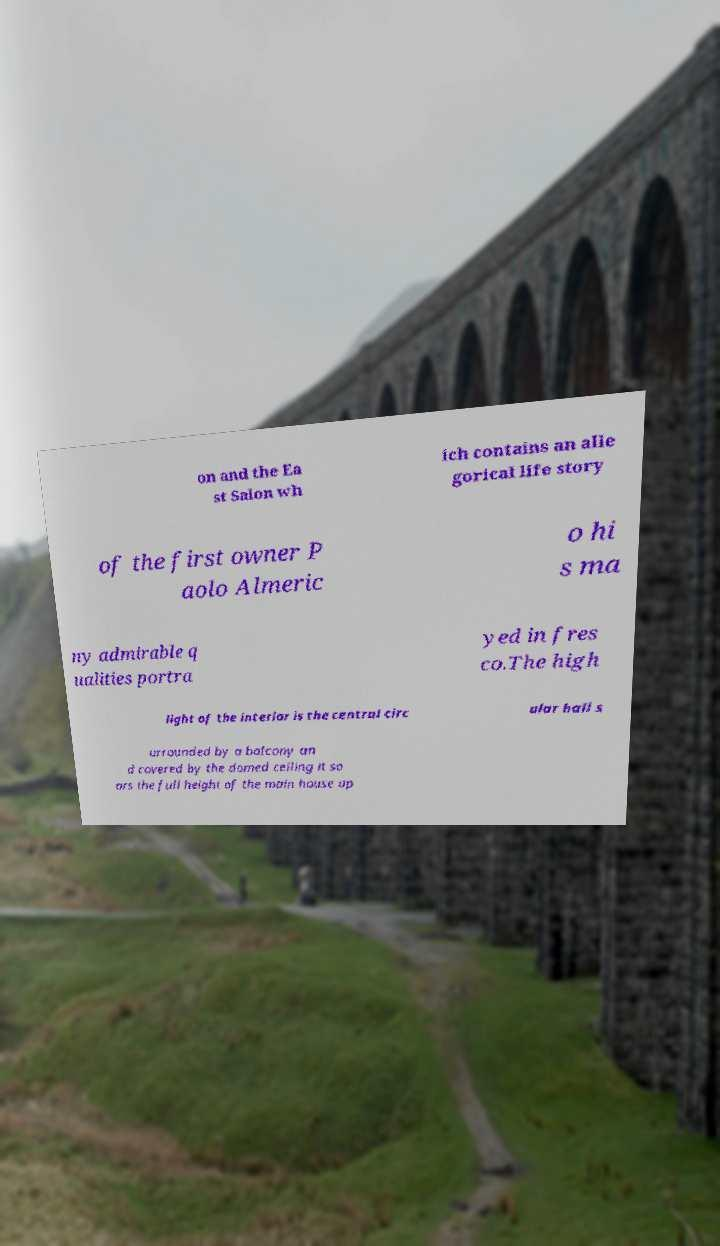Please read and relay the text visible in this image. What does it say? on and the Ea st Salon wh ich contains an alle gorical life story of the first owner P aolo Almeric o hi s ma ny admirable q ualities portra yed in fres co.The high light of the interior is the central circ ular hall s urrounded by a balcony an d covered by the domed ceiling it so ars the full height of the main house up 